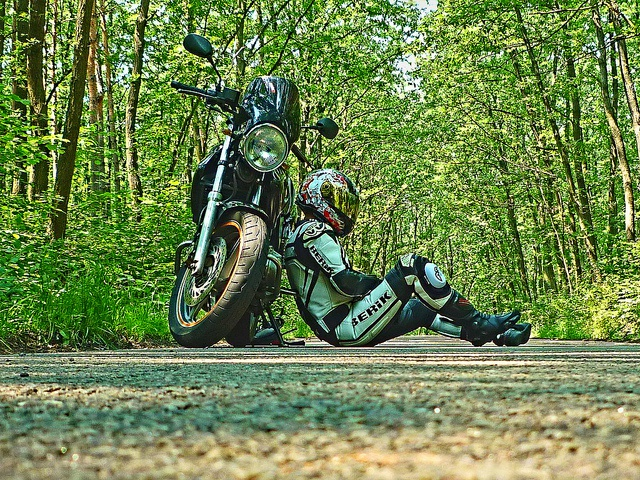Describe the objects in this image and their specific colors. I can see motorcycle in darkgreen, black, gray, and ivory tones and people in darkgreen, black, teal, and turquoise tones in this image. 